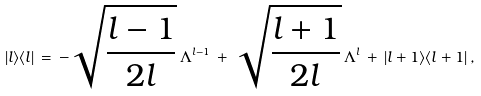<formula> <loc_0><loc_0><loc_500><loc_500>| l \rangle \langle l | \, = \, - \sqrt { \frac { l - 1 } { 2 l } } \, \Lambda ^ { l - 1 } \, + \, \sqrt { \frac { l + 1 } { 2 l } } \, \Lambda ^ { l } \, + \, | l + 1 \rangle \langle l + 1 | \, ,</formula> 